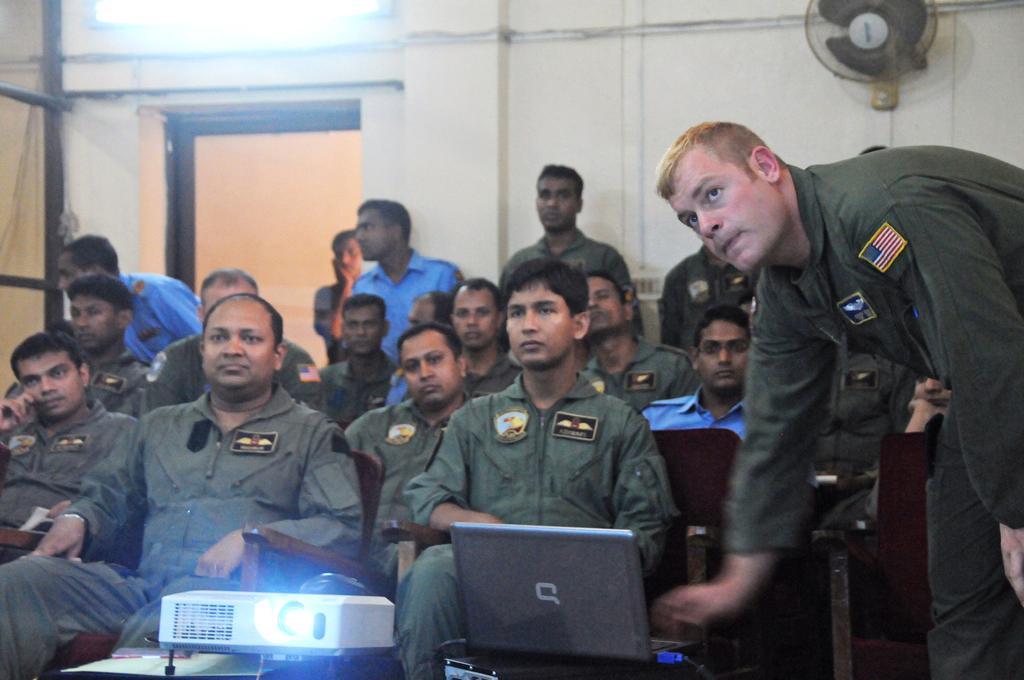Could you give a brief overview of what you see in this image? In this image, we can see some people sitting on the chairs, on the right side, we can see a man standing. There is a laptop and a projector. In the background, we can see the wall and a door. We can see a fan on the wall. 